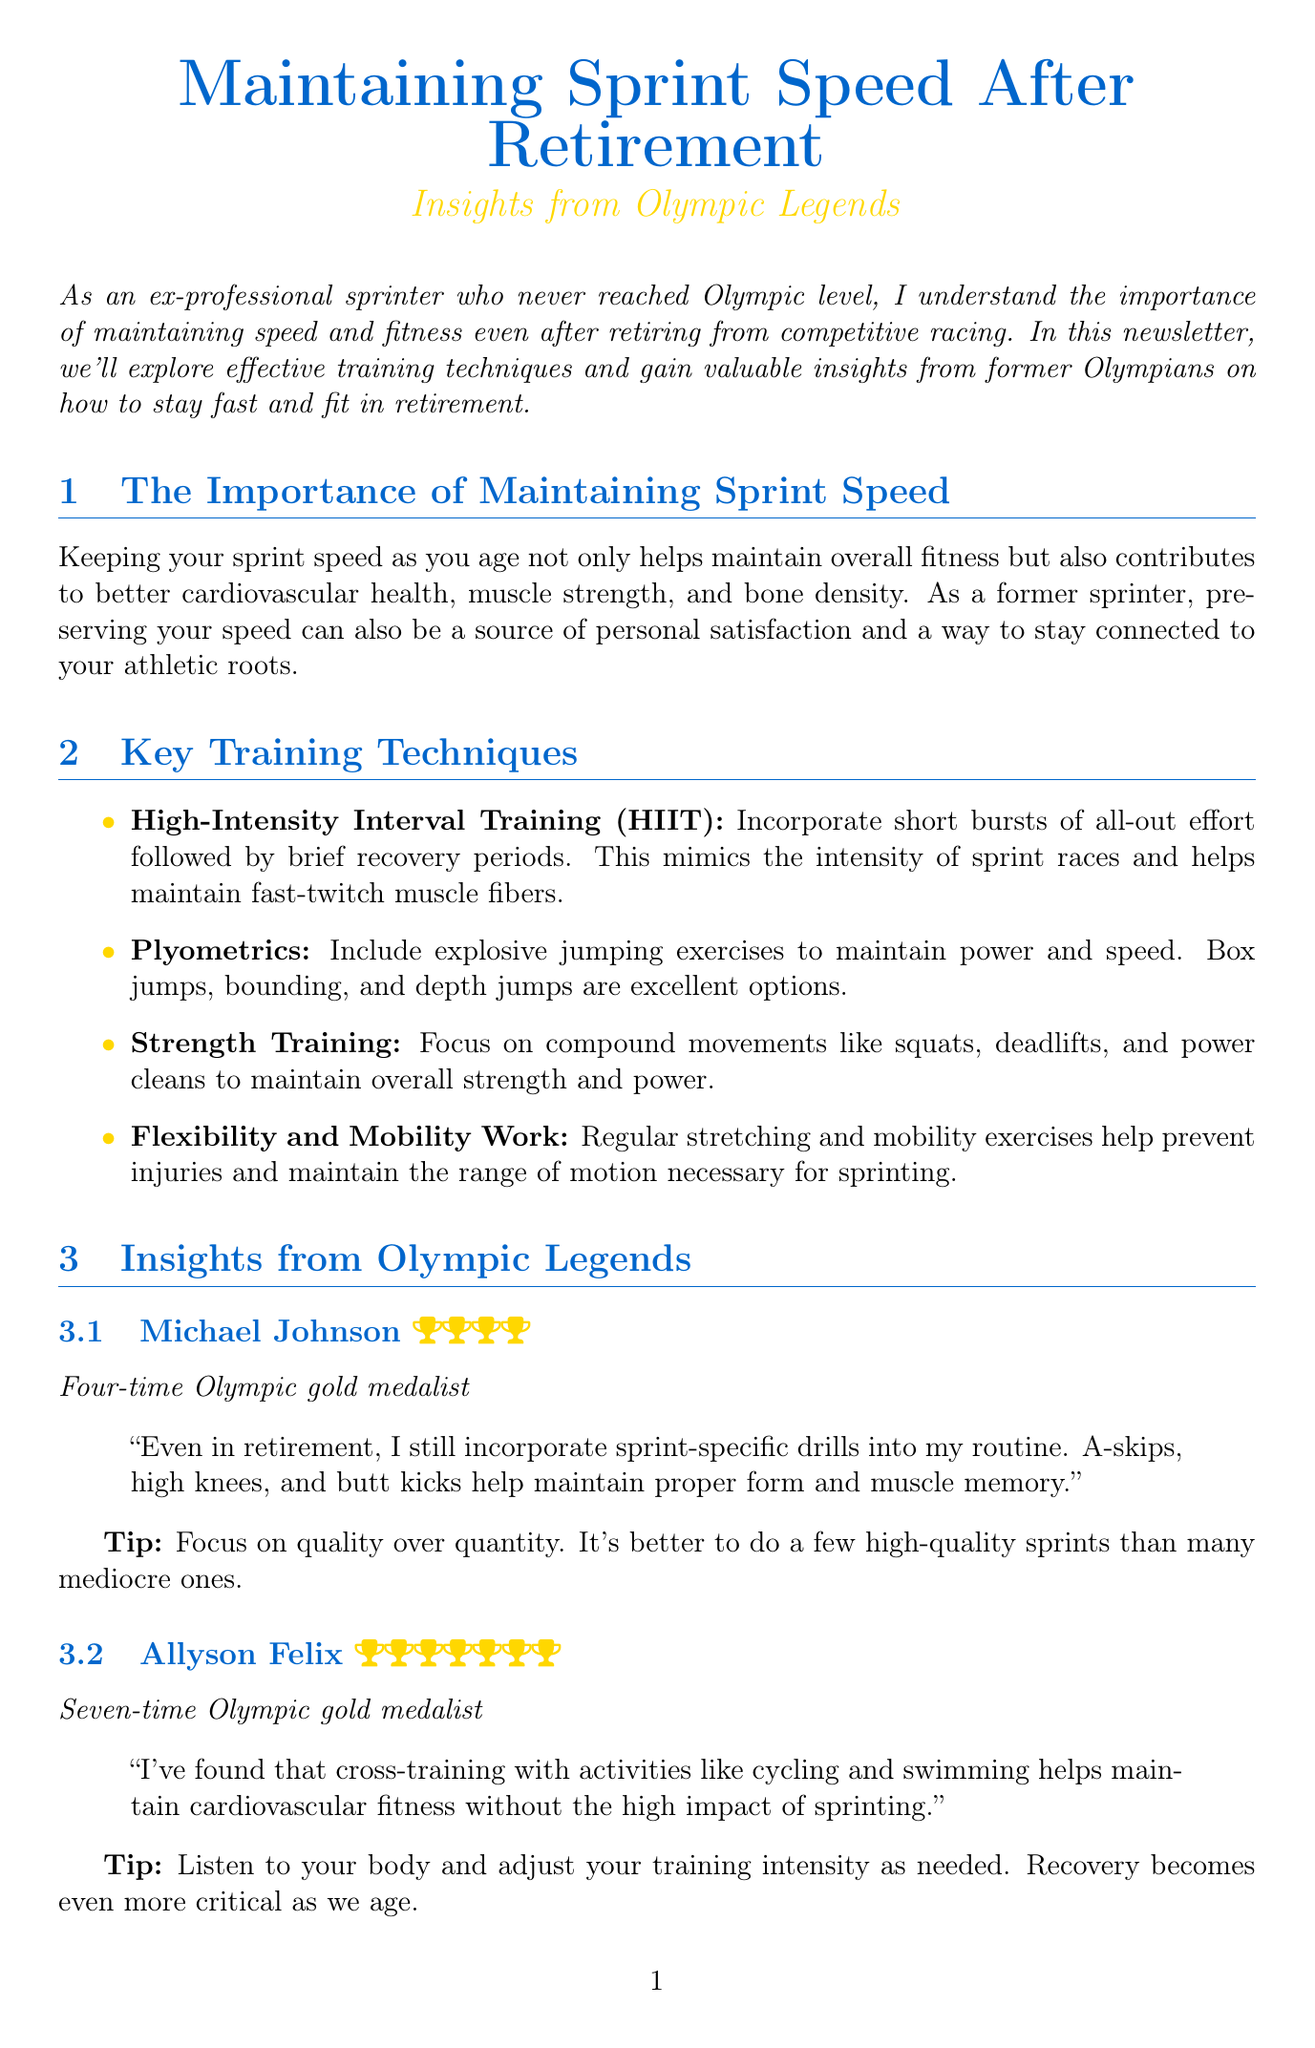What is the title of the newsletter? The title is explicitly stated in the document as the heading at the beginning.
Answer: Maintaining Sprint Speed After Retirement: Insights from Olympic Legends Who is a four-time Olympic gold medalist mentioned in the newsletter? The document includes interviews with several Olympic legends, naming Michael Johnson as a four-time gold medalist.
Answer: Michael Johnson What type of training involves explosive jumping exercises? The document details various training techniques, specifying plyometrics for explosive jumping exercises.
Answer: Plyometrics According to Usain Bolt, how often does he hit the track for light sprinting? Bolt's interview indicates the frequency of his track sessions for light sprinting.
Answer: Once or twice a week What is a key focus of nutrition for maintaining sprint speed? The newsletter elaborates on nutrition, highlighting lean proteins as a crucial aspect for muscle maintenance.
Answer: Lean proteins What should athletes consider on rest days according to the recovery section? The recovery section suggests an activity suggestion to maintain fitness without overstraining.
Answer: Low-impact activities What is a tip given by Allyson Felix related to training intensity? Felix's interview provides advice regarding adjusting training intensity based on one's body signals.
Answer: Listen to your body Why is maintaining sprint speed important as we age? The document discusses the benefits of maintaining sprint speed, pointing out several health aspects.
Answer: Better cardiovascular health What is the overall theme of the newsletter? The document emphasizes the aspect of post-retirement training for sprinters, reflecting the overall theme.
Answer: Maintaining speed and fitness in retirement 